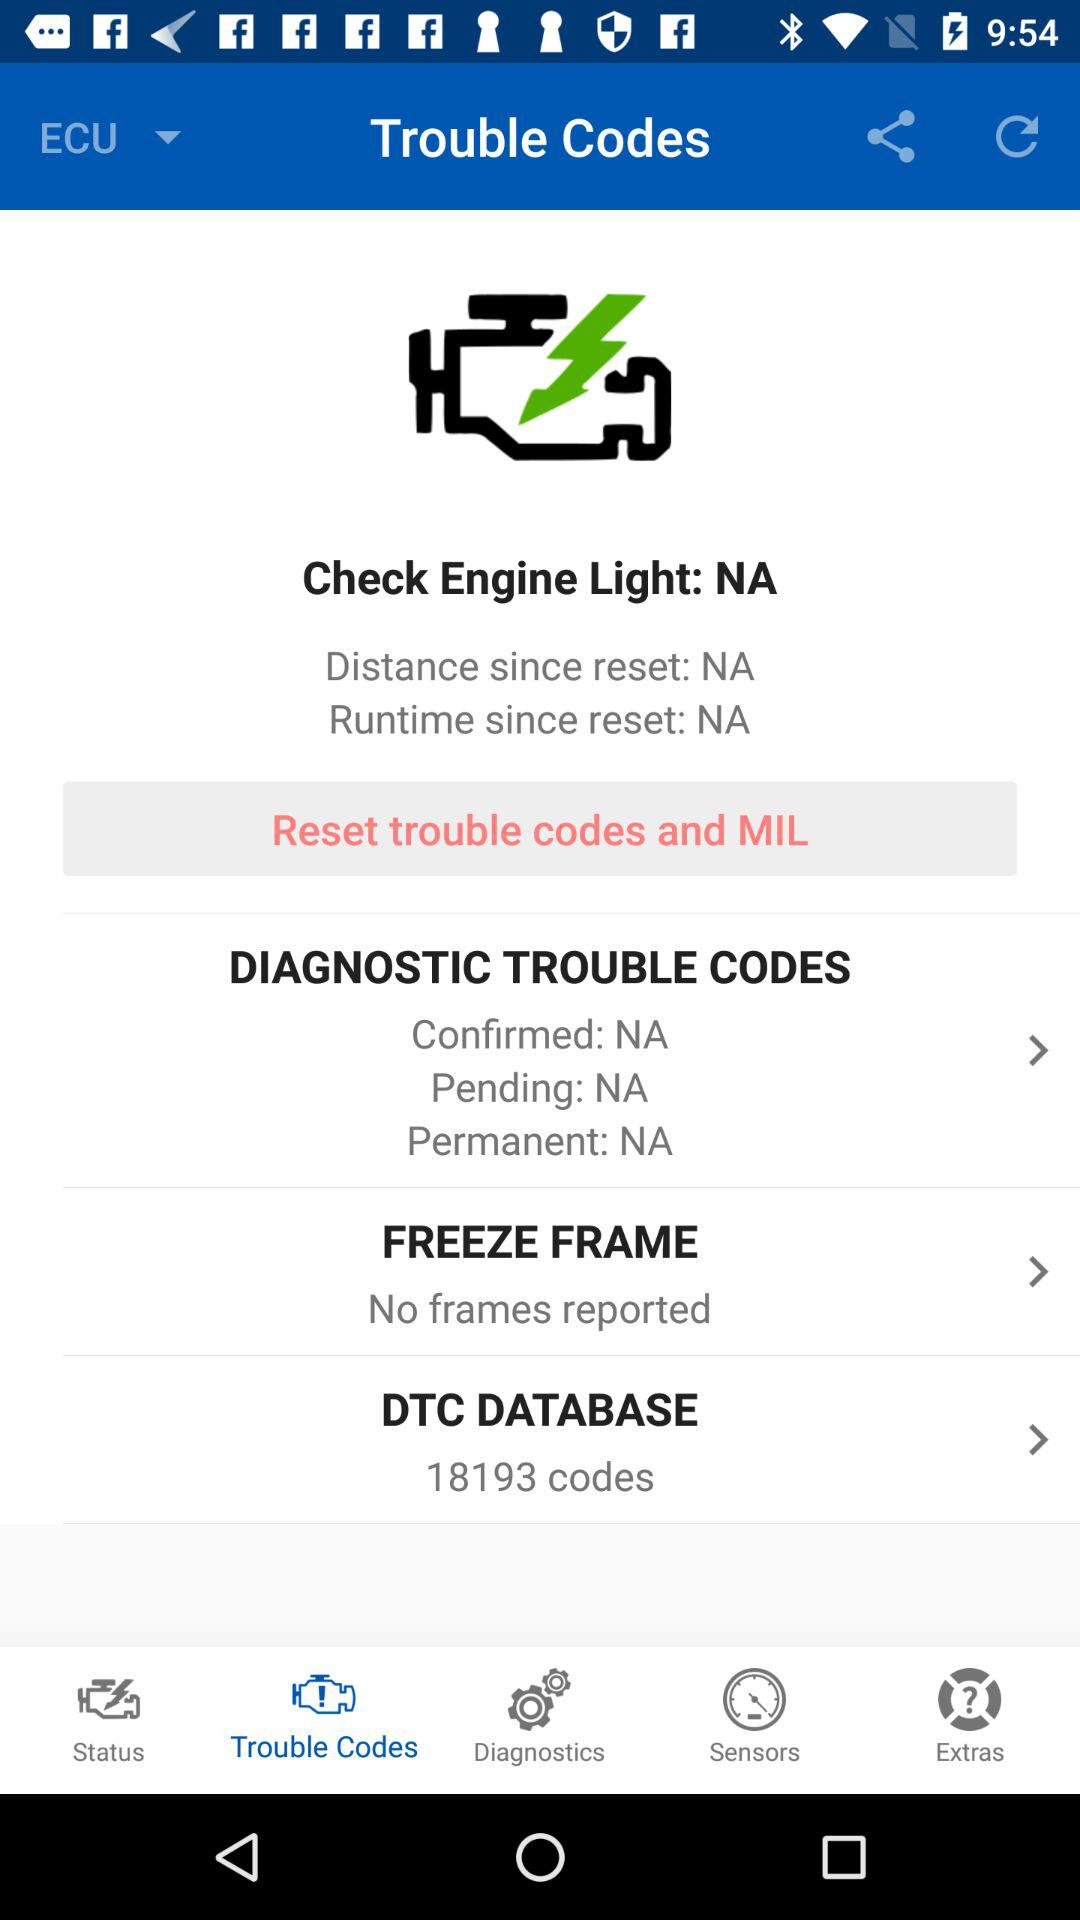What is the runtime since the reset? The runtime since the reset is NA. 